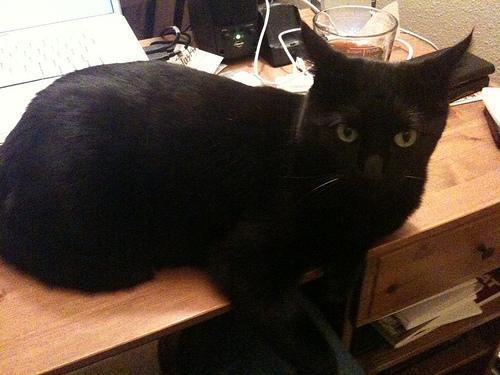How many cats are on the desk?
Give a very brief answer. 1. 